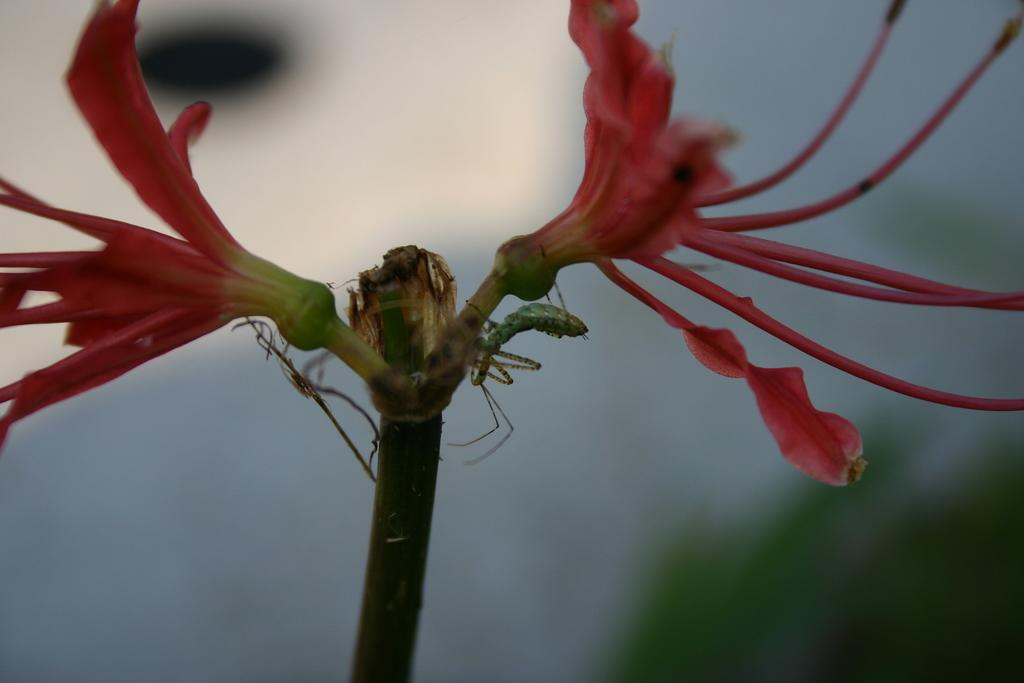What is the main subject in the foreground of the image? There is a plant with flowers in the foreground of the image. What can be observed about the background of the image? The background of the image is blurred. What type of blade is being used by the lawyer in the image? There is no lawyer or blade present in the image; it features a plant with flowers in the foreground and a blurred background. 